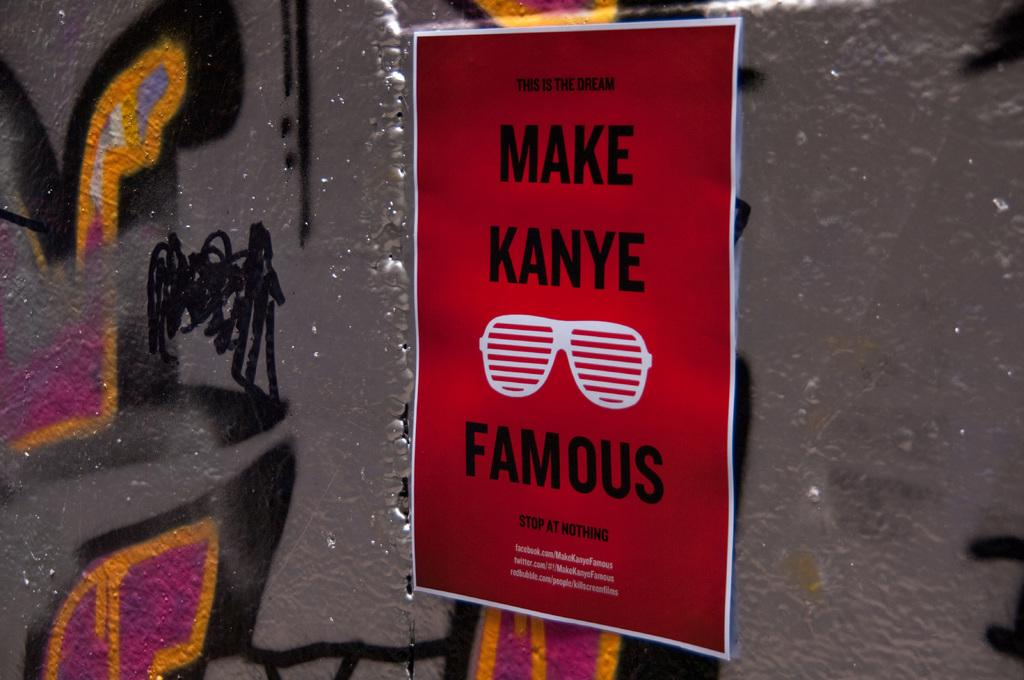Provide a one-sentence caption for the provided image. A poster on a graffiti backed wall says to Make Kanye Famous. 